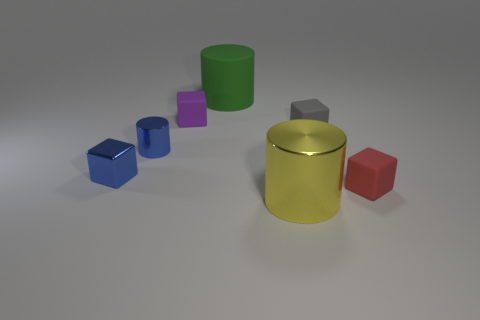Are there more blue blocks behind the big yellow object than tiny red blocks left of the tiny red block?
Provide a short and direct response. Yes. What number of other big metallic objects have the same shape as the big green object?
Your answer should be very brief. 1. What is the material of the gray block that is the same size as the blue metallic cylinder?
Keep it short and to the point. Rubber. Are there any tiny yellow cylinders made of the same material as the small purple block?
Your answer should be compact. No. Is the number of rubber cubes on the left side of the yellow metallic cylinder less than the number of small gray metal spheres?
Provide a short and direct response. No. The blue object that is in front of the metal cylinder that is on the left side of the big green cylinder is made of what material?
Offer a very short reply. Metal. What is the shape of the rubber object that is both in front of the large green cylinder and on the left side of the tiny gray cube?
Provide a succinct answer. Cube. What number of other objects are there of the same color as the large rubber thing?
Offer a very short reply. 0. How many objects are either blue things that are right of the tiny shiny block or small gray matte blocks?
Your response must be concise. 2. There is a metallic block; does it have the same color as the shiny cylinder left of the large green rubber cylinder?
Keep it short and to the point. Yes. 